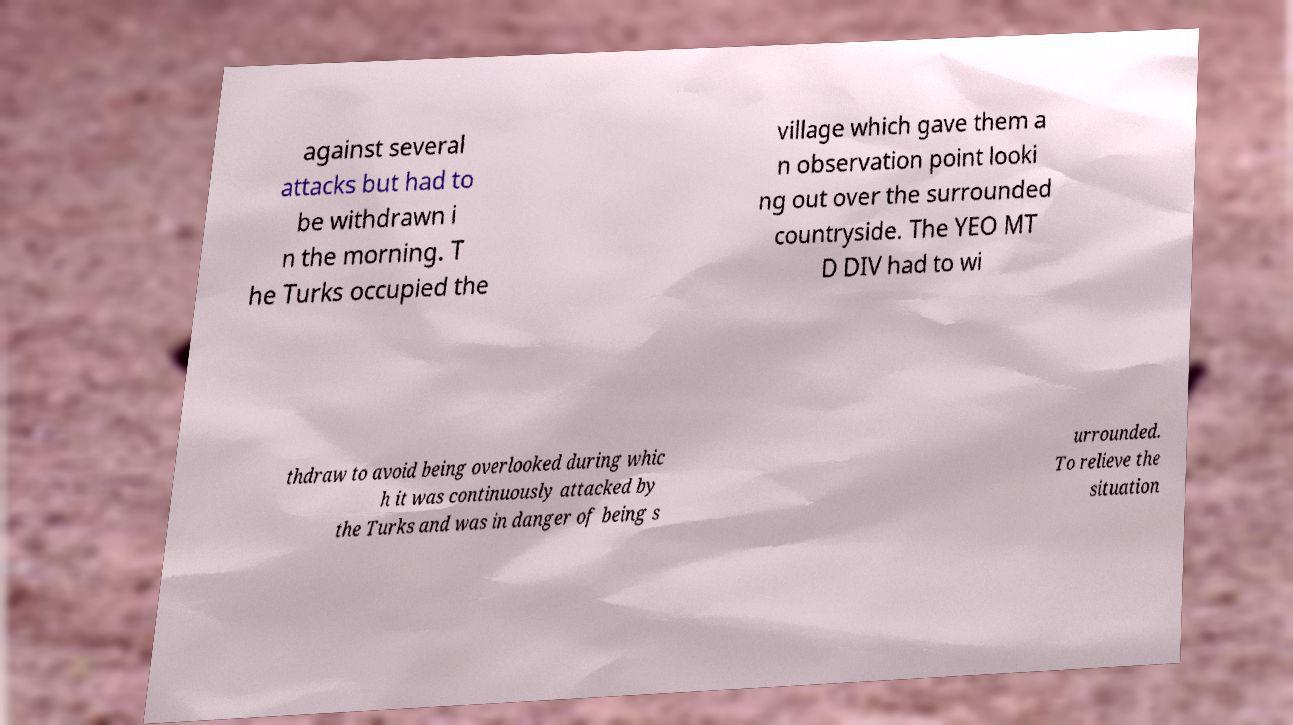I need the written content from this picture converted into text. Can you do that? against several attacks but had to be withdrawn i n the morning. T he Turks occupied the village which gave them a n observation point looki ng out over the surrounded countryside. The YEO MT D DIV had to wi thdraw to avoid being overlooked during whic h it was continuously attacked by the Turks and was in danger of being s urrounded. To relieve the situation 